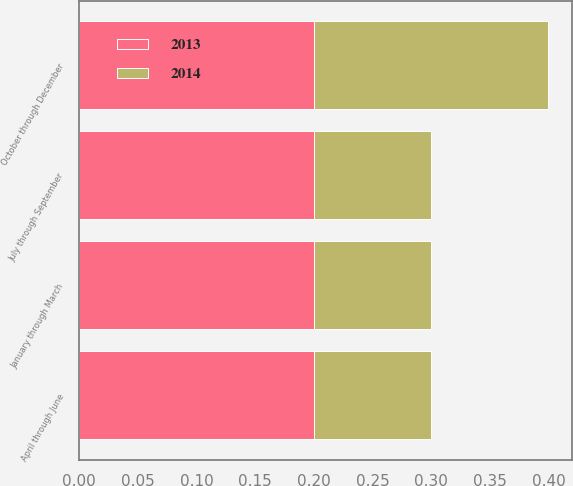Convert chart to OTSL. <chart><loc_0><loc_0><loc_500><loc_500><stacked_bar_chart><ecel><fcel>January through March<fcel>April through June<fcel>July through September<fcel>October through December<nl><fcel>2013<fcel>0.2<fcel>0.2<fcel>0.2<fcel>0.2<nl><fcel>2014<fcel>0.1<fcel>0.1<fcel>0.1<fcel>0.2<nl></chart> 